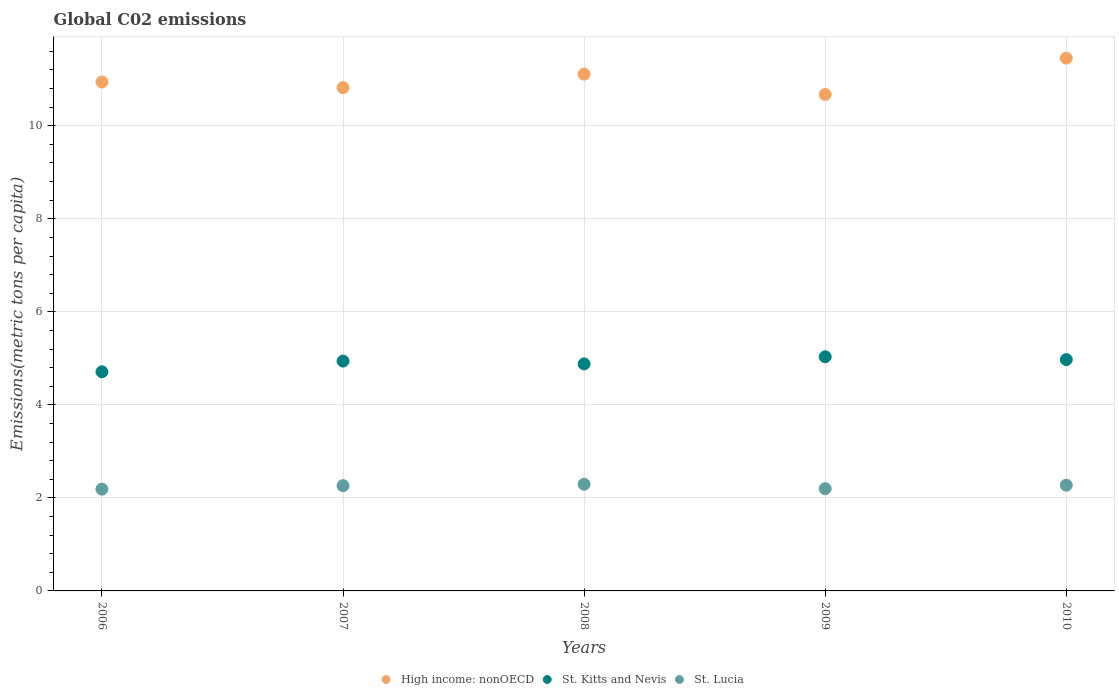How many different coloured dotlines are there?
Give a very brief answer. 3. What is the amount of CO2 emitted in in St. Kitts and Nevis in 2008?
Provide a short and direct response. 4.88. Across all years, what is the maximum amount of CO2 emitted in in St. Lucia?
Make the answer very short. 2.29. Across all years, what is the minimum amount of CO2 emitted in in St. Lucia?
Your answer should be compact. 2.19. In which year was the amount of CO2 emitted in in High income: nonOECD minimum?
Provide a succinct answer. 2009. What is the total amount of CO2 emitted in in High income: nonOECD in the graph?
Offer a very short reply. 55. What is the difference between the amount of CO2 emitted in in St. Lucia in 2006 and that in 2010?
Your response must be concise. -0.09. What is the difference between the amount of CO2 emitted in in St. Kitts and Nevis in 2008 and the amount of CO2 emitted in in St. Lucia in 2009?
Your answer should be very brief. 2.68. What is the average amount of CO2 emitted in in St. Lucia per year?
Offer a very short reply. 2.24. In the year 2006, what is the difference between the amount of CO2 emitted in in St. Kitts and Nevis and amount of CO2 emitted in in St. Lucia?
Make the answer very short. 2.52. What is the ratio of the amount of CO2 emitted in in St. Kitts and Nevis in 2006 to that in 2010?
Ensure brevity in your answer.  0.95. What is the difference between the highest and the second highest amount of CO2 emitted in in High income: nonOECD?
Your response must be concise. 0.34. What is the difference between the highest and the lowest amount of CO2 emitted in in St. Lucia?
Your answer should be compact. 0.11. In how many years, is the amount of CO2 emitted in in St. Lucia greater than the average amount of CO2 emitted in in St. Lucia taken over all years?
Ensure brevity in your answer.  3. Is the amount of CO2 emitted in in St. Kitts and Nevis strictly greater than the amount of CO2 emitted in in High income: nonOECD over the years?
Provide a short and direct response. No. How many dotlines are there?
Your answer should be very brief. 3. What is the difference between two consecutive major ticks on the Y-axis?
Offer a very short reply. 2. Are the values on the major ticks of Y-axis written in scientific E-notation?
Your answer should be very brief. No. Where does the legend appear in the graph?
Offer a very short reply. Bottom center. How many legend labels are there?
Your response must be concise. 3. How are the legend labels stacked?
Provide a short and direct response. Horizontal. What is the title of the graph?
Make the answer very short. Global C02 emissions. Does "Northern Mariana Islands" appear as one of the legend labels in the graph?
Offer a very short reply. No. What is the label or title of the Y-axis?
Give a very brief answer. Emissions(metric tons per capita). What is the Emissions(metric tons per capita) in High income: nonOECD in 2006?
Ensure brevity in your answer.  10.94. What is the Emissions(metric tons per capita) of St. Kitts and Nevis in 2006?
Provide a short and direct response. 4.71. What is the Emissions(metric tons per capita) of St. Lucia in 2006?
Make the answer very short. 2.19. What is the Emissions(metric tons per capita) of High income: nonOECD in 2007?
Provide a succinct answer. 10.82. What is the Emissions(metric tons per capita) in St. Kitts and Nevis in 2007?
Your response must be concise. 4.94. What is the Emissions(metric tons per capita) in St. Lucia in 2007?
Give a very brief answer. 2.26. What is the Emissions(metric tons per capita) of High income: nonOECD in 2008?
Offer a very short reply. 11.11. What is the Emissions(metric tons per capita) of St. Kitts and Nevis in 2008?
Your answer should be very brief. 4.88. What is the Emissions(metric tons per capita) of St. Lucia in 2008?
Offer a terse response. 2.29. What is the Emissions(metric tons per capita) in High income: nonOECD in 2009?
Provide a short and direct response. 10.67. What is the Emissions(metric tons per capita) in St. Kitts and Nevis in 2009?
Provide a short and direct response. 5.03. What is the Emissions(metric tons per capita) of St. Lucia in 2009?
Keep it short and to the point. 2.2. What is the Emissions(metric tons per capita) in High income: nonOECD in 2010?
Provide a short and direct response. 11.45. What is the Emissions(metric tons per capita) in St. Kitts and Nevis in 2010?
Ensure brevity in your answer.  4.97. What is the Emissions(metric tons per capita) of St. Lucia in 2010?
Your response must be concise. 2.27. Across all years, what is the maximum Emissions(metric tons per capita) in High income: nonOECD?
Provide a succinct answer. 11.45. Across all years, what is the maximum Emissions(metric tons per capita) in St. Kitts and Nevis?
Keep it short and to the point. 5.03. Across all years, what is the maximum Emissions(metric tons per capita) in St. Lucia?
Provide a short and direct response. 2.29. Across all years, what is the minimum Emissions(metric tons per capita) of High income: nonOECD?
Provide a succinct answer. 10.67. Across all years, what is the minimum Emissions(metric tons per capita) of St. Kitts and Nevis?
Provide a succinct answer. 4.71. Across all years, what is the minimum Emissions(metric tons per capita) in St. Lucia?
Keep it short and to the point. 2.19. What is the total Emissions(metric tons per capita) in High income: nonOECD in the graph?
Your response must be concise. 55. What is the total Emissions(metric tons per capita) in St. Kitts and Nevis in the graph?
Offer a terse response. 24.54. What is the total Emissions(metric tons per capita) in St. Lucia in the graph?
Offer a very short reply. 11.21. What is the difference between the Emissions(metric tons per capita) of High income: nonOECD in 2006 and that in 2007?
Provide a short and direct response. 0.12. What is the difference between the Emissions(metric tons per capita) in St. Kitts and Nevis in 2006 and that in 2007?
Offer a very short reply. -0.23. What is the difference between the Emissions(metric tons per capita) of St. Lucia in 2006 and that in 2007?
Give a very brief answer. -0.08. What is the difference between the Emissions(metric tons per capita) of High income: nonOECD in 2006 and that in 2008?
Your answer should be very brief. -0.17. What is the difference between the Emissions(metric tons per capita) of St. Kitts and Nevis in 2006 and that in 2008?
Provide a succinct answer. -0.17. What is the difference between the Emissions(metric tons per capita) in St. Lucia in 2006 and that in 2008?
Give a very brief answer. -0.11. What is the difference between the Emissions(metric tons per capita) of High income: nonOECD in 2006 and that in 2009?
Ensure brevity in your answer.  0.27. What is the difference between the Emissions(metric tons per capita) in St. Kitts and Nevis in 2006 and that in 2009?
Offer a very short reply. -0.32. What is the difference between the Emissions(metric tons per capita) in St. Lucia in 2006 and that in 2009?
Your response must be concise. -0.01. What is the difference between the Emissions(metric tons per capita) in High income: nonOECD in 2006 and that in 2010?
Your response must be concise. -0.51. What is the difference between the Emissions(metric tons per capita) in St. Kitts and Nevis in 2006 and that in 2010?
Your answer should be very brief. -0.26. What is the difference between the Emissions(metric tons per capita) of St. Lucia in 2006 and that in 2010?
Keep it short and to the point. -0.09. What is the difference between the Emissions(metric tons per capita) in High income: nonOECD in 2007 and that in 2008?
Your response must be concise. -0.29. What is the difference between the Emissions(metric tons per capita) in St. Kitts and Nevis in 2007 and that in 2008?
Make the answer very short. 0.06. What is the difference between the Emissions(metric tons per capita) of St. Lucia in 2007 and that in 2008?
Provide a succinct answer. -0.03. What is the difference between the Emissions(metric tons per capita) of High income: nonOECD in 2007 and that in 2009?
Provide a short and direct response. 0.15. What is the difference between the Emissions(metric tons per capita) of St. Kitts and Nevis in 2007 and that in 2009?
Your response must be concise. -0.09. What is the difference between the Emissions(metric tons per capita) in St. Lucia in 2007 and that in 2009?
Make the answer very short. 0.07. What is the difference between the Emissions(metric tons per capita) in High income: nonOECD in 2007 and that in 2010?
Make the answer very short. -0.63. What is the difference between the Emissions(metric tons per capita) in St. Kitts and Nevis in 2007 and that in 2010?
Ensure brevity in your answer.  -0.03. What is the difference between the Emissions(metric tons per capita) in St. Lucia in 2007 and that in 2010?
Your response must be concise. -0.01. What is the difference between the Emissions(metric tons per capita) of High income: nonOECD in 2008 and that in 2009?
Ensure brevity in your answer.  0.44. What is the difference between the Emissions(metric tons per capita) of St. Kitts and Nevis in 2008 and that in 2009?
Give a very brief answer. -0.15. What is the difference between the Emissions(metric tons per capita) of St. Lucia in 2008 and that in 2009?
Provide a short and direct response. 0.1. What is the difference between the Emissions(metric tons per capita) of High income: nonOECD in 2008 and that in 2010?
Ensure brevity in your answer.  -0.34. What is the difference between the Emissions(metric tons per capita) in St. Kitts and Nevis in 2008 and that in 2010?
Your response must be concise. -0.09. What is the difference between the Emissions(metric tons per capita) of St. Lucia in 2008 and that in 2010?
Give a very brief answer. 0.02. What is the difference between the Emissions(metric tons per capita) in High income: nonOECD in 2009 and that in 2010?
Offer a very short reply. -0.78. What is the difference between the Emissions(metric tons per capita) of St. Kitts and Nevis in 2009 and that in 2010?
Provide a succinct answer. 0.06. What is the difference between the Emissions(metric tons per capita) of St. Lucia in 2009 and that in 2010?
Offer a terse response. -0.08. What is the difference between the Emissions(metric tons per capita) of High income: nonOECD in 2006 and the Emissions(metric tons per capita) of St. Kitts and Nevis in 2007?
Offer a very short reply. 6. What is the difference between the Emissions(metric tons per capita) in High income: nonOECD in 2006 and the Emissions(metric tons per capita) in St. Lucia in 2007?
Offer a very short reply. 8.68. What is the difference between the Emissions(metric tons per capita) of St. Kitts and Nevis in 2006 and the Emissions(metric tons per capita) of St. Lucia in 2007?
Your response must be concise. 2.45. What is the difference between the Emissions(metric tons per capita) in High income: nonOECD in 2006 and the Emissions(metric tons per capita) in St. Kitts and Nevis in 2008?
Your response must be concise. 6.06. What is the difference between the Emissions(metric tons per capita) of High income: nonOECD in 2006 and the Emissions(metric tons per capita) of St. Lucia in 2008?
Your response must be concise. 8.65. What is the difference between the Emissions(metric tons per capita) of St. Kitts and Nevis in 2006 and the Emissions(metric tons per capita) of St. Lucia in 2008?
Provide a short and direct response. 2.42. What is the difference between the Emissions(metric tons per capita) of High income: nonOECD in 2006 and the Emissions(metric tons per capita) of St. Kitts and Nevis in 2009?
Offer a terse response. 5.91. What is the difference between the Emissions(metric tons per capita) of High income: nonOECD in 2006 and the Emissions(metric tons per capita) of St. Lucia in 2009?
Provide a succinct answer. 8.74. What is the difference between the Emissions(metric tons per capita) in St. Kitts and Nevis in 2006 and the Emissions(metric tons per capita) in St. Lucia in 2009?
Make the answer very short. 2.51. What is the difference between the Emissions(metric tons per capita) of High income: nonOECD in 2006 and the Emissions(metric tons per capita) of St. Kitts and Nevis in 2010?
Make the answer very short. 5.97. What is the difference between the Emissions(metric tons per capita) in High income: nonOECD in 2006 and the Emissions(metric tons per capita) in St. Lucia in 2010?
Offer a terse response. 8.67. What is the difference between the Emissions(metric tons per capita) of St. Kitts and Nevis in 2006 and the Emissions(metric tons per capita) of St. Lucia in 2010?
Provide a succinct answer. 2.44. What is the difference between the Emissions(metric tons per capita) in High income: nonOECD in 2007 and the Emissions(metric tons per capita) in St. Kitts and Nevis in 2008?
Provide a succinct answer. 5.94. What is the difference between the Emissions(metric tons per capita) of High income: nonOECD in 2007 and the Emissions(metric tons per capita) of St. Lucia in 2008?
Provide a succinct answer. 8.53. What is the difference between the Emissions(metric tons per capita) of St. Kitts and Nevis in 2007 and the Emissions(metric tons per capita) of St. Lucia in 2008?
Provide a succinct answer. 2.65. What is the difference between the Emissions(metric tons per capita) of High income: nonOECD in 2007 and the Emissions(metric tons per capita) of St. Kitts and Nevis in 2009?
Keep it short and to the point. 5.79. What is the difference between the Emissions(metric tons per capita) of High income: nonOECD in 2007 and the Emissions(metric tons per capita) of St. Lucia in 2009?
Keep it short and to the point. 8.62. What is the difference between the Emissions(metric tons per capita) in St. Kitts and Nevis in 2007 and the Emissions(metric tons per capita) in St. Lucia in 2009?
Your answer should be very brief. 2.74. What is the difference between the Emissions(metric tons per capita) in High income: nonOECD in 2007 and the Emissions(metric tons per capita) in St. Kitts and Nevis in 2010?
Keep it short and to the point. 5.85. What is the difference between the Emissions(metric tons per capita) of High income: nonOECD in 2007 and the Emissions(metric tons per capita) of St. Lucia in 2010?
Ensure brevity in your answer.  8.55. What is the difference between the Emissions(metric tons per capita) of St. Kitts and Nevis in 2007 and the Emissions(metric tons per capita) of St. Lucia in 2010?
Your answer should be compact. 2.67. What is the difference between the Emissions(metric tons per capita) of High income: nonOECD in 2008 and the Emissions(metric tons per capita) of St. Kitts and Nevis in 2009?
Your answer should be very brief. 6.08. What is the difference between the Emissions(metric tons per capita) in High income: nonOECD in 2008 and the Emissions(metric tons per capita) in St. Lucia in 2009?
Provide a short and direct response. 8.91. What is the difference between the Emissions(metric tons per capita) of St. Kitts and Nevis in 2008 and the Emissions(metric tons per capita) of St. Lucia in 2009?
Keep it short and to the point. 2.68. What is the difference between the Emissions(metric tons per capita) of High income: nonOECD in 2008 and the Emissions(metric tons per capita) of St. Kitts and Nevis in 2010?
Provide a succinct answer. 6.14. What is the difference between the Emissions(metric tons per capita) of High income: nonOECD in 2008 and the Emissions(metric tons per capita) of St. Lucia in 2010?
Offer a very short reply. 8.84. What is the difference between the Emissions(metric tons per capita) in St. Kitts and Nevis in 2008 and the Emissions(metric tons per capita) in St. Lucia in 2010?
Keep it short and to the point. 2.61. What is the difference between the Emissions(metric tons per capita) of High income: nonOECD in 2009 and the Emissions(metric tons per capita) of St. Kitts and Nevis in 2010?
Offer a very short reply. 5.7. What is the difference between the Emissions(metric tons per capita) in High income: nonOECD in 2009 and the Emissions(metric tons per capita) in St. Lucia in 2010?
Your response must be concise. 8.4. What is the difference between the Emissions(metric tons per capita) of St. Kitts and Nevis in 2009 and the Emissions(metric tons per capita) of St. Lucia in 2010?
Offer a very short reply. 2.76. What is the average Emissions(metric tons per capita) in High income: nonOECD per year?
Offer a terse response. 11. What is the average Emissions(metric tons per capita) of St. Kitts and Nevis per year?
Give a very brief answer. 4.91. What is the average Emissions(metric tons per capita) of St. Lucia per year?
Make the answer very short. 2.24. In the year 2006, what is the difference between the Emissions(metric tons per capita) in High income: nonOECD and Emissions(metric tons per capita) in St. Kitts and Nevis?
Offer a terse response. 6.23. In the year 2006, what is the difference between the Emissions(metric tons per capita) of High income: nonOECD and Emissions(metric tons per capita) of St. Lucia?
Ensure brevity in your answer.  8.75. In the year 2006, what is the difference between the Emissions(metric tons per capita) in St. Kitts and Nevis and Emissions(metric tons per capita) in St. Lucia?
Keep it short and to the point. 2.52. In the year 2007, what is the difference between the Emissions(metric tons per capita) of High income: nonOECD and Emissions(metric tons per capita) of St. Kitts and Nevis?
Your answer should be very brief. 5.88. In the year 2007, what is the difference between the Emissions(metric tons per capita) of High income: nonOECD and Emissions(metric tons per capita) of St. Lucia?
Give a very brief answer. 8.56. In the year 2007, what is the difference between the Emissions(metric tons per capita) in St. Kitts and Nevis and Emissions(metric tons per capita) in St. Lucia?
Give a very brief answer. 2.68. In the year 2008, what is the difference between the Emissions(metric tons per capita) of High income: nonOECD and Emissions(metric tons per capita) of St. Kitts and Nevis?
Keep it short and to the point. 6.23. In the year 2008, what is the difference between the Emissions(metric tons per capita) of High income: nonOECD and Emissions(metric tons per capita) of St. Lucia?
Ensure brevity in your answer.  8.82. In the year 2008, what is the difference between the Emissions(metric tons per capita) in St. Kitts and Nevis and Emissions(metric tons per capita) in St. Lucia?
Your response must be concise. 2.59. In the year 2009, what is the difference between the Emissions(metric tons per capita) of High income: nonOECD and Emissions(metric tons per capita) of St. Kitts and Nevis?
Make the answer very short. 5.64. In the year 2009, what is the difference between the Emissions(metric tons per capita) of High income: nonOECD and Emissions(metric tons per capita) of St. Lucia?
Provide a short and direct response. 8.47. In the year 2009, what is the difference between the Emissions(metric tons per capita) of St. Kitts and Nevis and Emissions(metric tons per capita) of St. Lucia?
Ensure brevity in your answer.  2.84. In the year 2010, what is the difference between the Emissions(metric tons per capita) in High income: nonOECD and Emissions(metric tons per capita) in St. Kitts and Nevis?
Give a very brief answer. 6.48. In the year 2010, what is the difference between the Emissions(metric tons per capita) of High income: nonOECD and Emissions(metric tons per capita) of St. Lucia?
Offer a very short reply. 9.18. In the year 2010, what is the difference between the Emissions(metric tons per capita) in St. Kitts and Nevis and Emissions(metric tons per capita) in St. Lucia?
Keep it short and to the point. 2.7. What is the ratio of the Emissions(metric tons per capita) of High income: nonOECD in 2006 to that in 2007?
Your answer should be very brief. 1.01. What is the ratio of the Emissions(metric tons per capita) in St. Kitts and Nevis in 2006 to that in 2007?
Offer a terse response. 0.95. What is the ratio of the Emissions(metric tons per capita) in St. Lucia in 2006 to that in 2007?
Give a very brief answer. 0.97. What is the ratio of the Emissions(metric tons per capita) of St. Kitts and Nevis in 2006 to that in 2008?
Your response must be concise. 0.97. What is the ratio of the Emissions(metric tons per capita) in St. Lucia in 2006 to that in 2008?
Make the answer very short. 0.95. What is the ratio of the Emissions(metric tons per capita) of High income: nonOECD in 2006 to that in 2009?
Offer a very short reply. 1.03. What is the ratio of the Emissions(metric tons per capita) in St. Kitts and Nevis in 2006 to that in 2009?
Ensure brevity in your answer.  0.94. What is the ratio of the Emissions(metric tons per capita) of High income: nonOECD in 2006 to that in 2010?
Ensure brevity in your answer.  0.96. What is the ratio of the Emissions(metric tons per capita) of St. Kitts and Nevis in 2006 to that in 2010?
Your answer should be very brief. 0.95. What is the ratio of the Emissions(metric tons per capita) of St. Lucia in 2006 to that in 2010?
Keep it short and to the point. 0.96. What is the ratio of the Emissions(metric tons per capita) in St. Kitts and Nevis in 2007 to that in 2008?
Give a very brief answer. 1.01. What is the ratio of the Emissions(metric tons per capita) in St. Lucia in 2007 to that in 2008?
Make the answer very short. 0.99. What is the ratio of the Emissions(metric tons per capita) in High income: nonOECD in 2007 to that in 2009?
Offer a terse response. 1.01. What is the ratio of the Emissions(metric tons per capita) of St. Kitts and Nevis in 2007 to that in 2009?
Your response must be concise. 0.98. What is the ratio of the Emissions(metric tons per capita) in St. Lucia in 2007 to that in 2009?
Your answer should be very brief. 1.03. What is the ratio of the Emissions(metric tons per capita) in High income: nonOECD in 2007 to that in 2010?
Offer a terse response. 0.94. What is the ratio of the Emissions(metric tons per capita) of St. Kitts and Nevis in 2007 to that in 2010?
Your answer should be compact. 0.99. What is the ratio of the Emissions(metric tons per capita) in St. Lucia in 2007 to that in 2010?
Provide a succinct answer. 1. What is the ratio of the Emissions(metric tons per capita) of High income: nonOECD in 2008 to that in 2009?
Offer a terse response. 1.04. What is the ratio of the Emissions(metric tons per capita) in St. Kitts and Nevis in 2008 to that in 2009?
Ensure brevity in your answer.  0.97. What is the ratio of the Emissions(metric tons per capita) in St. Lucia in 2008 to that in 2009?
Keep it short and to the point. 1.04. What is the ratio of the Emissions(metric tons per capita) of High income: nonOECD in 2008 to that in 2010?
Ensure brevity in your answer.  0.97. What is the ratio of the Emissions(metric tons per capita) in St. Kitts and Nevis in 2008 to that in 2010?
Offer a very short reply. 0.98. What is the ratio of the Emissions(metric tons per capita) of St. Lucia in 2008 to that in 2010?
Keep it short and to the point. 1.01. What is the ratio of the Emissions(metric tons per capita) in High income: nonOECD in 2009 to that in 2010?
Keep it short and to the point. 0.93. What is the ratio of the Emissions(metric tons per capita) of St. Kitts and Nevis in 2009 to that in 2010?
Your answer should be very brief. 1.01. What is the ratio of the Emissions(metric tons per capita) in St. Lucia in 2009 to that in 2010?
Your response must be concise. 0.97. What is the difference between the highest and the second highest Emissions(metric tons per capita) in High income: nonOECD?
Ensure brevity in your answer.  0.34. What is the difference between the highest and the second highest Emissions(metric tons per capita) in St. Kitts and Nevis?
Your answer should be very brief. 0.06. What is the difference between the highest and the second highest Emissions(metric tons per capita) in St. Lucia?
Offer a terse response. 0.02. What is the difference between the highest and the lowest Emissions(metric tons per capita) in High income: nonOECD?
Your answer should be very brief. 0.78. What is the difference between the highest and the lowest Emissions(metric tons per capita) in St. Kitts and Nevis?
Your answer should be compact. 0.32. What is the difference between the highest and the lowest Emissions(metric tons per capita) in St. Lucia?
Your answer should be compact. 0.11. 